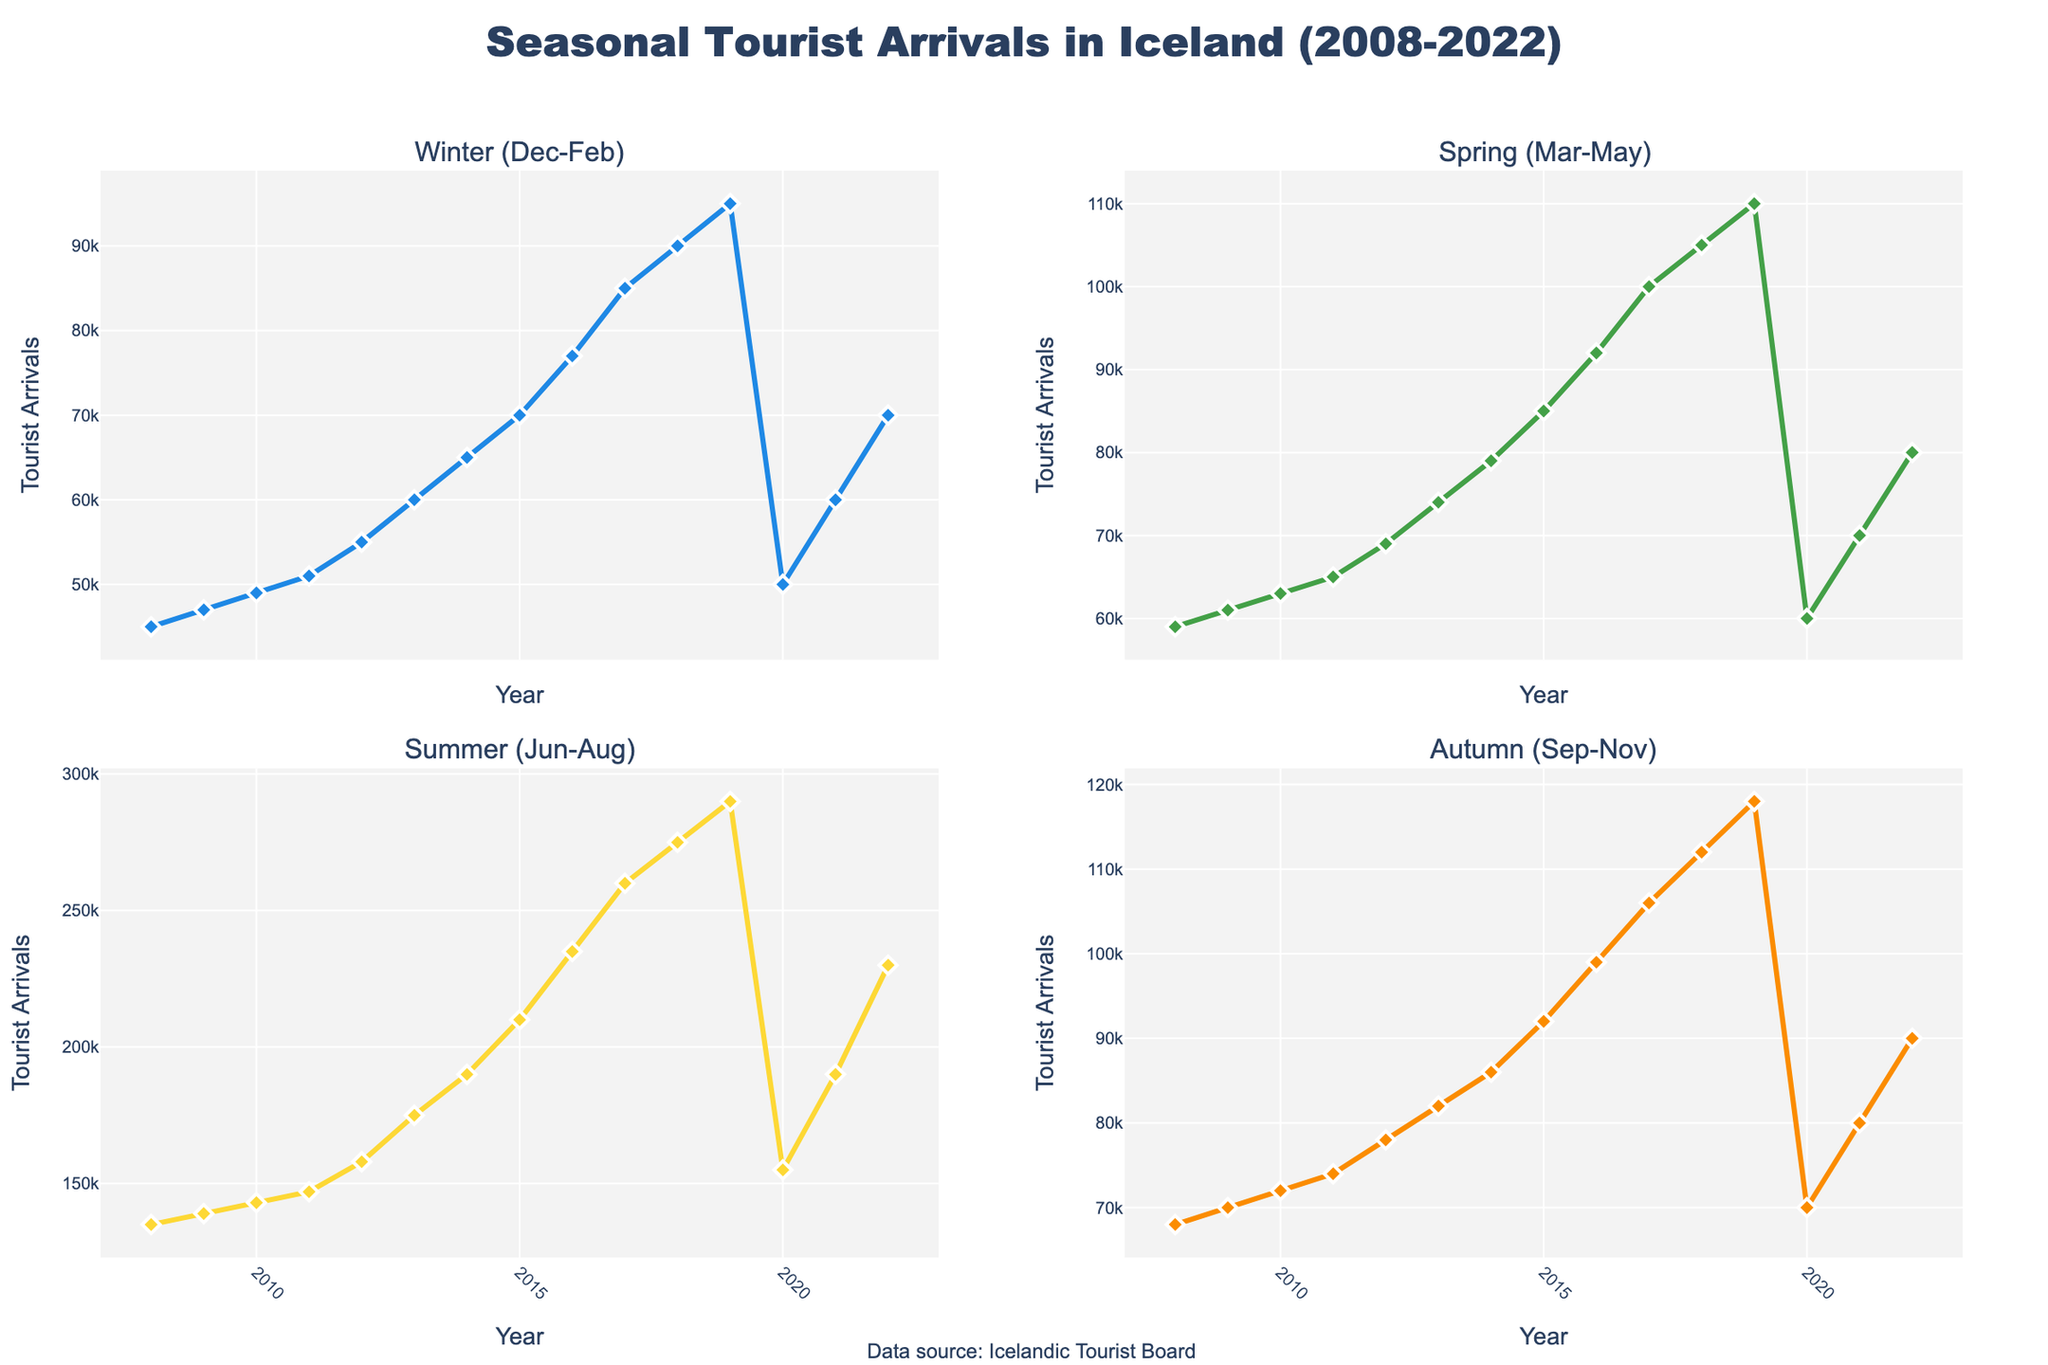What is the title of the figure? The title of the figure is displayed at the top center. It reads "Seasonal Tourist Arrivals in Iceland (2008-2022)".
Answer: Seasonal Tourist Arrivals in Iceland (2008-2022) In which year did Winter tourists first exceed 50,000? By looking at the Winter (Dec-Feb) sub-plot, we see the value exceeds 50,000 in 2010.
Answer: 2010 Which season had the highest tourist arrivals in 2022? By examining the values for 2022 in all four sub-plots, Summer (Jun-Aug) with 230,000 arrivals is the highest.
Answer: Summer (Jun-Aug) How did the tourist arrivals in Summer 2019 compare to Summer 2020? Compare the data points for Summer (Jun-Aug) in 2019 and 2020 sub-plots. The arrivals in 2019 were 290,000, while in 2020 it was 155,000, showing a significant decrease.
Answer: They decreased What is the overall trend in Summer tourist arrivals from 2008 to 2022? Reviewing the Summer sub-plot, there is a steady increase in tourist arrivals from 2008 until 2019, followed by a dip in 2020, and then a recovery by 2022.
Answer: Increasing trend with a mid dip Calculate the average Autumn tourist arrivals from 2008 to 2022. Sum the Autumn (Sep-Nov) tourist arrivals from 2008 to 2022 (68,000 + 70,000 + 72,000 + 74,000 + 78,000 + 82,000 + 86,000 + 92,000 + 99,000 + 106,000 + 112,000 + 118,000 + 70,000 + 80,000 + 90,000) = 1,299,000. Divide by 15 (number of years) to find the average.
Answer: Average = 1,299,000 / 15 = 86,600 Which season showed the largest increase in tourist arrivals between 2008 and 2022? Check the difference for each season from the start (2008) to the end (2022). Winter (25,000 increase), Spring (31,000 increase), Summer (95,000 increase), and Autumn (22,000 increase). Summer shows the largest increase.
Answer: Summer (Jun-Aug) Did the tourist arrivals in Winter ever decrease from one year to the next? Observing the Winter (Dec-Feb) sub-plot, a decrease is noticed between 2019 and 2020, where it drops from 95,000 to 50,000.
Answer: Yes, between 2019 and 2020 How does the trend in Spring tourist arrivals compare with Summer tourist arrivals from 2008 to 2022? From the Spring (Mar-May) and Summer (Jun-Aug) sub-plots, Spring has a relatively steady increase, while Summer sees a steep increase with a dip around 2020 before continuing to rise.
Answer: Spring is steady; Summer is steeper with a dip What was the impact of the 2020 drop on overall tourist arrivals across all seasons? Each season shows a visible drop in 2020. Winter falls from 95,000 to 50,000, Spring from 110,000 to 60,000, Summer from 290,000 to 155,000, and Autumn from 118,000 to 70,000. The overall tourist arrivals dropped visibly in 2020 for all seasons.
Answer: Significant drop in all seasons in 2020 